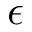Convert formula to latex. <formula><loc_0><loc_0><loc_500><loc_500>\epsilon</formula> 